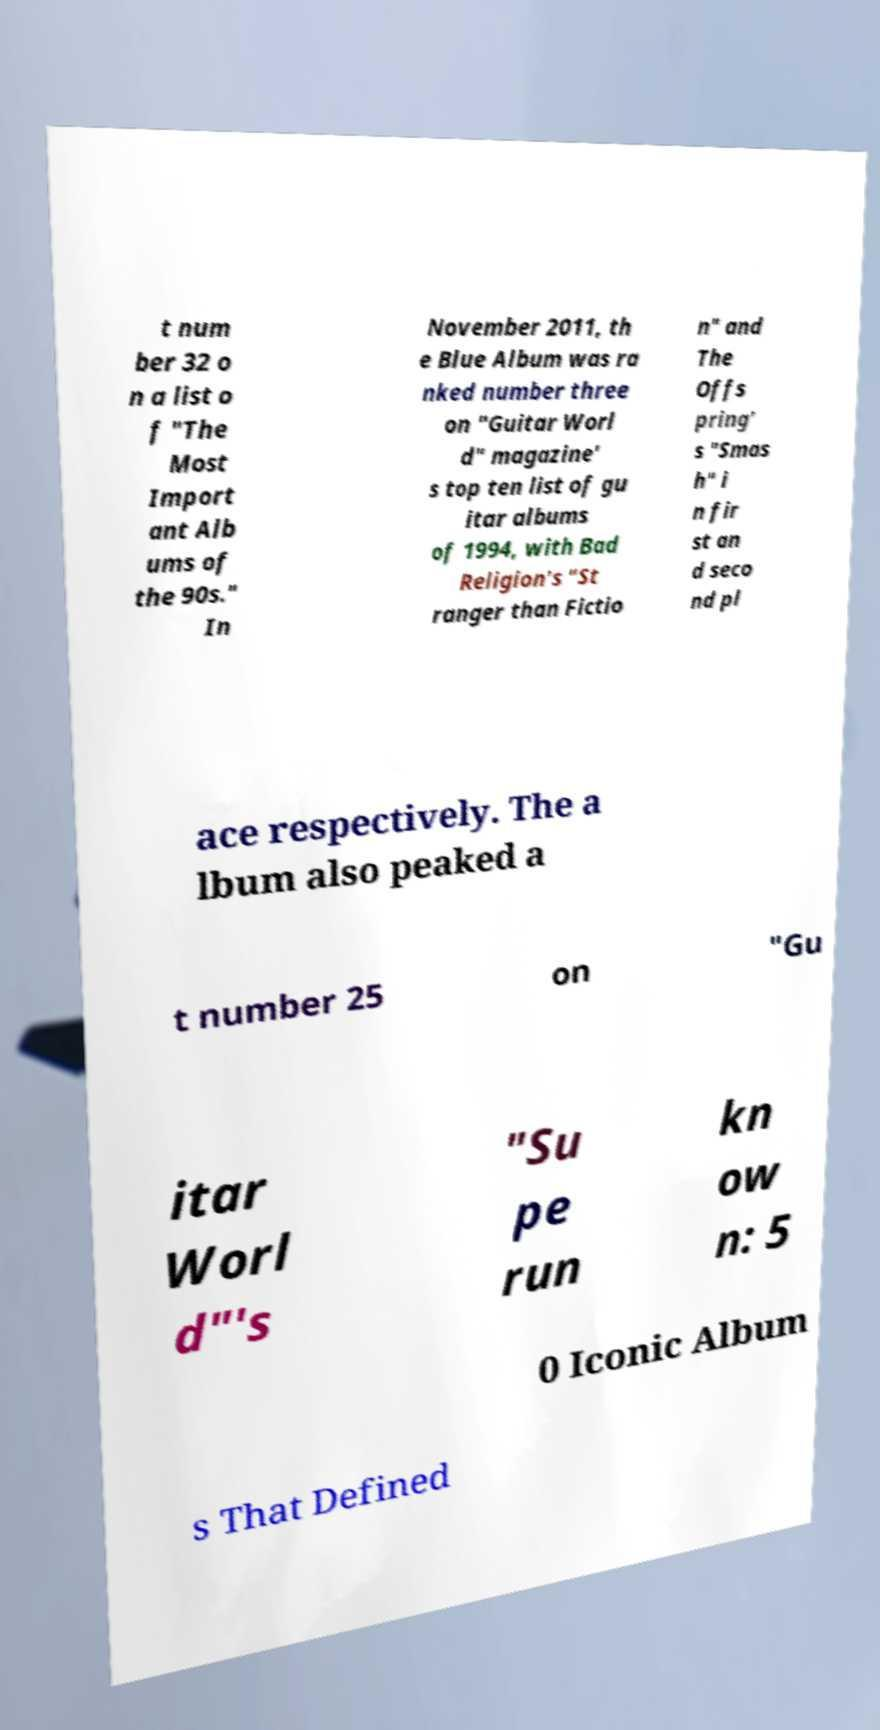For documentation purposes, I need the text within this image transcribed. Could you provide that? t num ber 32 o n a list o f "The Most Import ant Alb ums of the 90s." In November 2011, th e Blue Album was ra nked number three on "Guitar Worl d" magazine' s top ten list of gu itar albums of 1994, with Bad Religion's "St ranger than Fictio n" and The Offs pring' s "Smas h" i n fir st an d seco nd pl ace respectively. The a lbum also peaked a t number 25 on "Gu itar Worl d"'s "Su pe run kn ow n: 5 0 Iconic Album s That Defined 